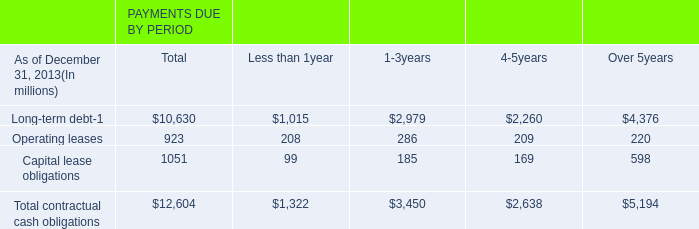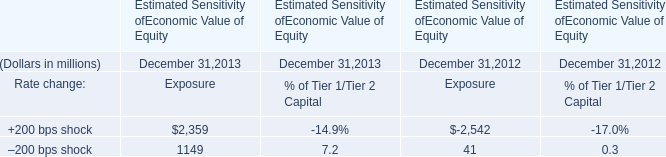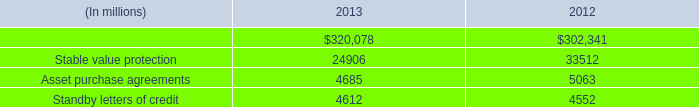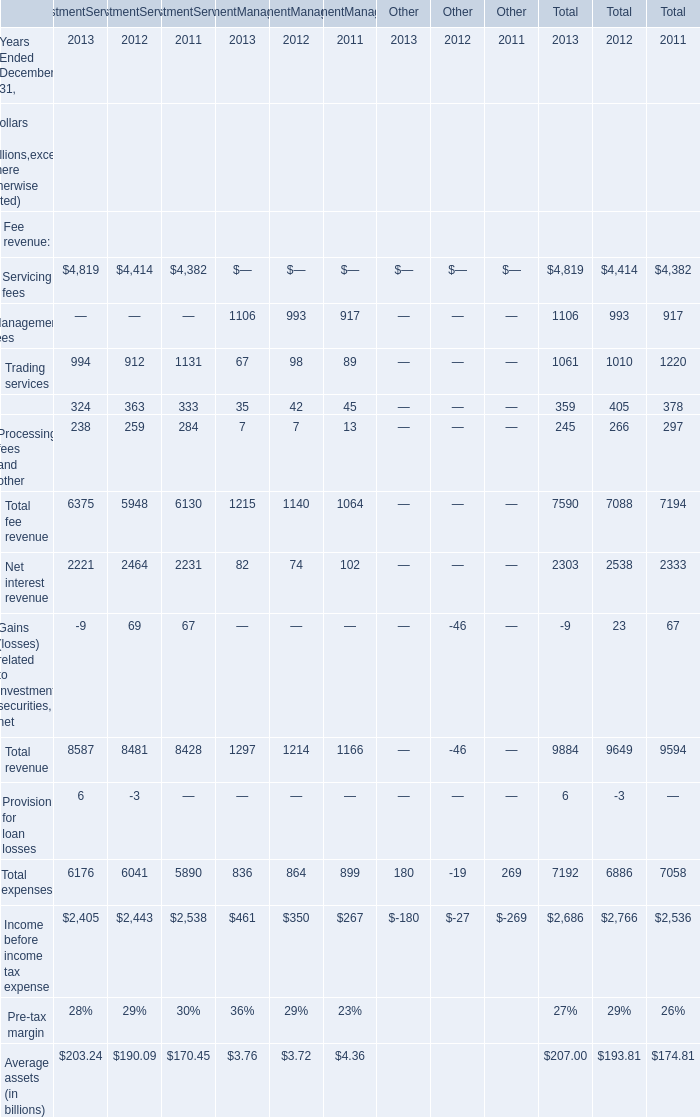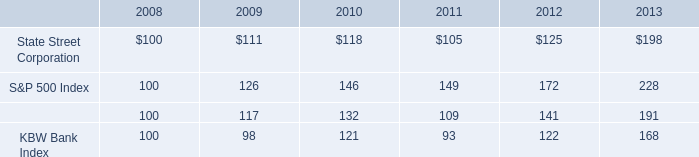what percent increase would shareholders receive between 2008 and 2013? 
Computations: ((198 - 100) / 100)
Answer: 0.98. 